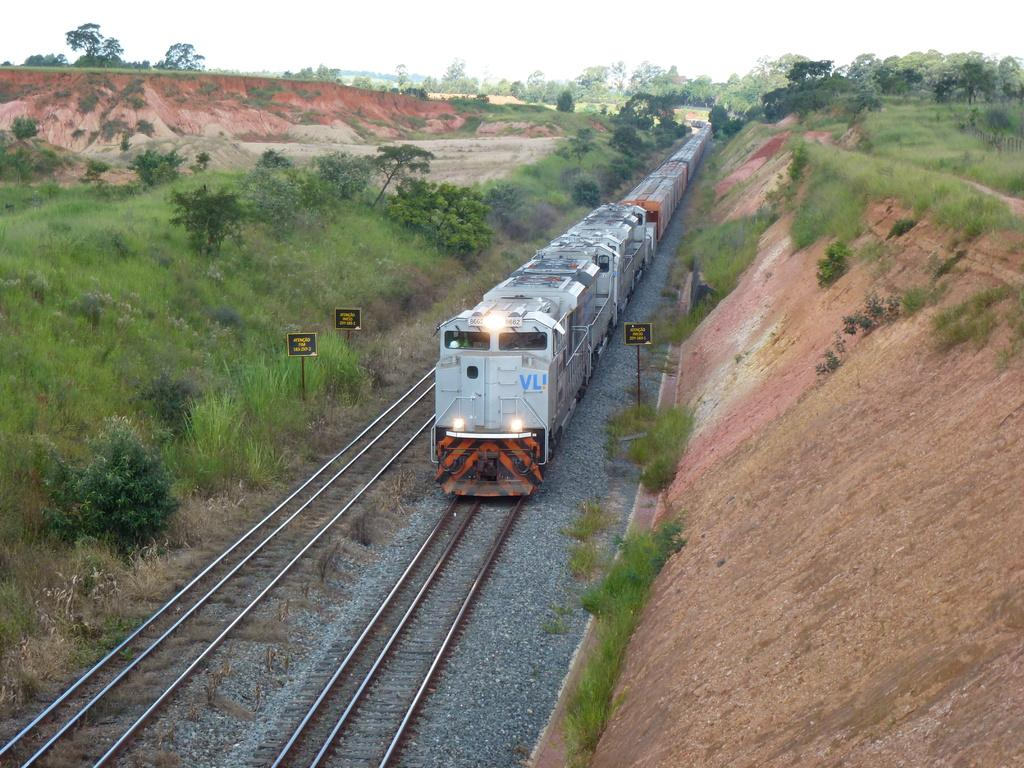What is the main subject in the center of the image? There is a train in the center of the image. What is the train's position in relation to the tracks? The train is on the tracks. What else can be seen in the image besides the train? There are poles and greenery in the image. How many hands are visible holding a test and a ticket in the image? There are no hands, tests, or tickets visible in the image; it features a train on tracks with poles and greenery. 